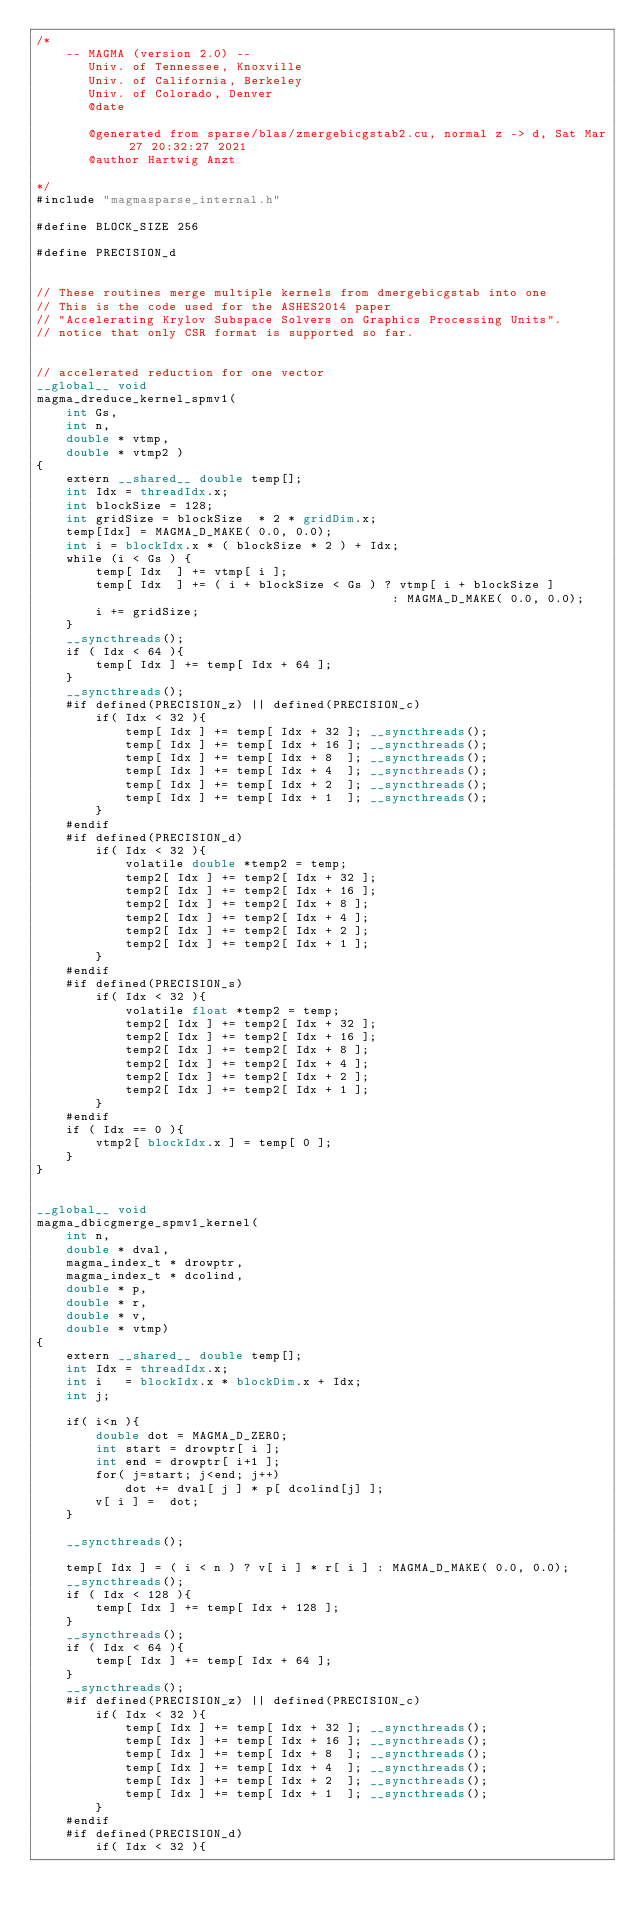Convert code to text. <code><loc_0><loc_0><loc_500><loc_500><_Cuda_>/*
    -- MAGMA (version 2.0) --
       Univ. of Tennessee, Knoxville
       Univ. of California, Berkeley
       Univ. of Colorado, Denver
       @date

       @generated from sparse/blas/zmergebicgstab2.cu, normal z -> d, Sat Mar 27 20:32:27 2021
       @author Hartwig Anzt

*/
#include "magmasparse_internal.h"

#define BLOCK_SIZE 256

#define PRECISION_d


// These routines merge multiple kernels from dmergebicgstab into one
// This is the code used for the ASHES2014 paper
// "Accelerating Krylov Subspace Solvers on Graphics Processing Units".
// notice that only CSR format is supported so far.


// accelerated reduction for one vector
__global__ void
magma_dreduce_kernel_spmv1(    
    int Gs,
    int n, 
    double * vtmp,
    double * vtmp2 )
{
    extern __shared__ double temp[];    
    int Idx = threadIdx.x;
    int blockSize = 128;
    int gridSize = blockSize  * 2 * gridDim.x; 
    temp[Idx] = MAGMA_D_MAKE( 0.0, 0.0);
    int i = blockIdx.x * ( blockSize * 2 ) + Idx;   
    while (i < Gs ) {
        temp[ Idx  ] += vtmp[ i ]; 
        temp[ Idx  ] += ( i + blockSize < Gs ) ? vtmp[ i + blockSize ] 
                                                : MAGMA_D_MAKE( 0.0, 0.0); 
        i += gridSize;
    }
    __syncthreads();
    if ( Idx < 64 ){
        temp[ Idx ] += temp[ Idx + 64 ];
    }
    __syncthreads();
    #if defined(PRECISION_z) || defined(PRECISION_c)
        if( Idx < 32 ){
            temp[ Idx ] += temp[ Idx + 32 ]; __syncthreads();
            temp[ Idx ] += temp[ Idx + 16 ]; __syncthreads();
            temp[ Idx ] += temp[ Idx + 8  ]; __syncthreads();
            temp[ Idx ] += temp[ Idx + 4  ]; __syncthreads();
            temp[ Idx ] += temp[ Idx + 2  ]; __syncthreads();
            temp[ Idx ] += temp[ Idx + 1  ]; __syncthreads();
        }
    #endif
    #if defined(PRECISION_d)
        if( Idx < 32 ){
            volatile double *temp2 = temp;
            temp2[ Idx ] += temp2[ Idx + 32 ];
            temp2[ Idx ] += temp2[ Idx + 16 ];
            temp2[ Idx ] += temp2[ Idx + 8 ];
            temp2[ Idx ] += temp2[ Idx + 4 ];
            temp2[ Idx ] += temp2[ Idx + 2 ];
            temp2[ Idx ] += temp2[ Idx + 1 ];
        }
    #endif
    #if defined(PRECISION_s)
        if( Idx < 32 ){
            volatile float *temp2 = temp;
            temp2[ Idx ] += temp2[ Idx + 32 ];
            temp2[ Idx ] += temp2[ Idx + 16 ];
            temp2[ Idx ] += temp2[ Idx + 8 ];
            temp2[ Idx ] += temp2[ Idx + 4 ];
            temp2[ Idx ] += temp2[ Idx + 2 ];
            temp2[ Idx ] += temp2[ Idx + 1 ];
        }
    #endif
    if ( Idx == 0 ){
        vtmp2[ blockIdx.x ] = temp[ 0 ];
    }
}


__global__ void
magma_dbicgmerge_spmv1_kernel(  
    int n,
    double * dval, 
    magma_index_t * drowptr, 
    magma_index_t * dcolind,
    double * p,
    double * r,
    double * v,
    double * vtmp)
{
    extern __shared__ double temp[]; 
    int Idx = threadIdx.x;   
    int i   = blockIdx.x * blockDim.x + Idx;
    int j;

    if( i<n ){
        double dot = MAGMA_D_ZERO;
        int start = drowptr[ i ];
        int end = drowptr[ i+1 ];
        for( j=start; j<end; j++)
            dot += dval[ j ] * p[ dcolind[j] ];
        v[ i ] =  dot;
    }

    __syncthreads(); 

    temp[ Idx ] = ( i < n ) ? v[ i ] * r[ i ] : MAGMA_D_MAKE( 0.0, 0.0);
    __syncthreads();
    if ( Idx < 128 ){
        temp[ Idx ] += temp[ Idx + 128 ];
    }
    __syncthreads();
    if ( Idx < 64 ){
        temp[ Idx ] += temp[ Idx + 64 ];
    }
    __syncthreads();
    #if defined(PRECISION_z) || defined(PRECISION_c)
        if( Idx < 32 ){
            temp[ Idx ] += temp[ Idx + 32 ]; __syncthreads();
            temp[ Idx ] += temp[ Idx + 16 ]; __syncthreads();
            temp[ Idx ] += temp[ Idx + 8  ]; __syncthreads();
            temp[ Idx ] += temp[ Idx + 4  ]; __syncthreads();
            temp[ Idx ] += temp[ Idx + 2  ]; __syncthreads();
            temp[ Idx ] += temp[ Idx + 1  ]; __syncthreads();
        }
    #endif
    #if defined(PRECISION_d)
        if( Idx < 32 ){</code> 